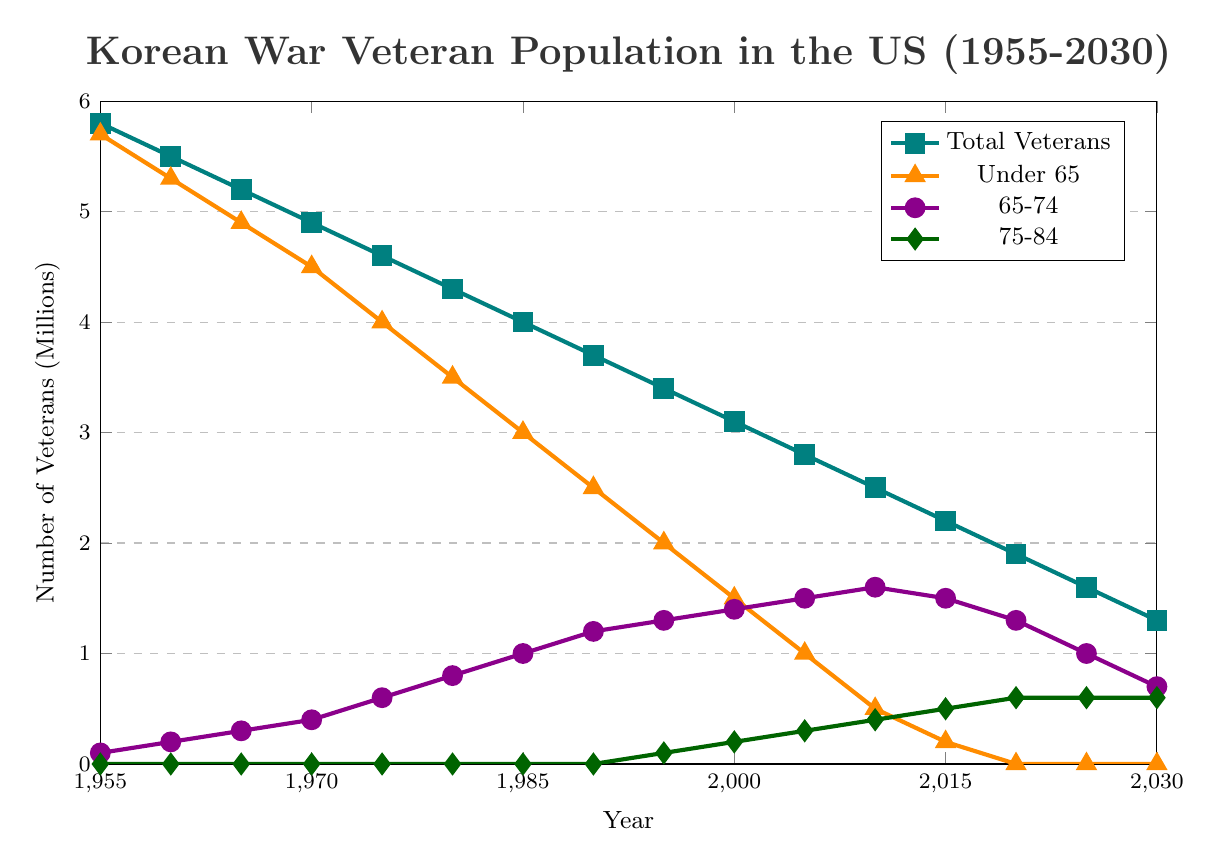What is the total number of Korean War veterans in 1970? Locate the point on the "Total Veterans" line corresponding to the year 1970, which is labeled as 4.9 million.
Answer: 4.9 million How many veterans aged 65-74 are there in 1995? Look at the "65-74" line for 1995, which is marked as 1.3 million.
Answer: 1.3 million Which age group had the highest number of veterans in 2010? Compare the values for all age groups in 2010. The line for the "65-74" group has the highest value at 1.6 million.
Answer: 65-74 What is the difference in the number of veterans aged under 65 between 1955 and 2020? Find the values for the "Under 65" line for 1955 (5.7 million) and 2020 (0 million). The difference is 5.7 - 0 = 5.7 million.
Answer: 5.7 million What is the trend for the total number of veterans from 1955 to 2030? Observe the "Total Veterans" line which shows a decreasing trend from 5.8 million in 1955 to 1.3 million in 2030.
Answer: Decreasing What age group starts appearing in the veteran population after 1990? Notice the "75-84" line starts from 0 and has its first non-zero value in 1995 (0.1 million).
Answer: 75-84 In which year do veterans aged 75-84 reach 0.6 million? Locate the "75-84" line, which reaches 0.6 million in 2020, 2025, and 2030.
Answer: 2020, 2025, 2030 How does the number of veterans aged 65-74 change from 2000 to 2030? Check for the "65-74" group values in 2000 (1.4 million) and 2030 (0.7 million), indicating a decrease by 0.7 million.
Answer: Decreasing What is the sum of veterans aged 65-74 and 75-84 in 2015? Add the values for the "65-74" group (1.5 million) and the "75-84" group (0.5 million) in 2015: 1.5 + 0.5 = 2 million.
Answer: 2 million How many veterans aged under 65 are there in 2025? The "Under 65" line for 2025 shows the value is zero.
Answer: 0 